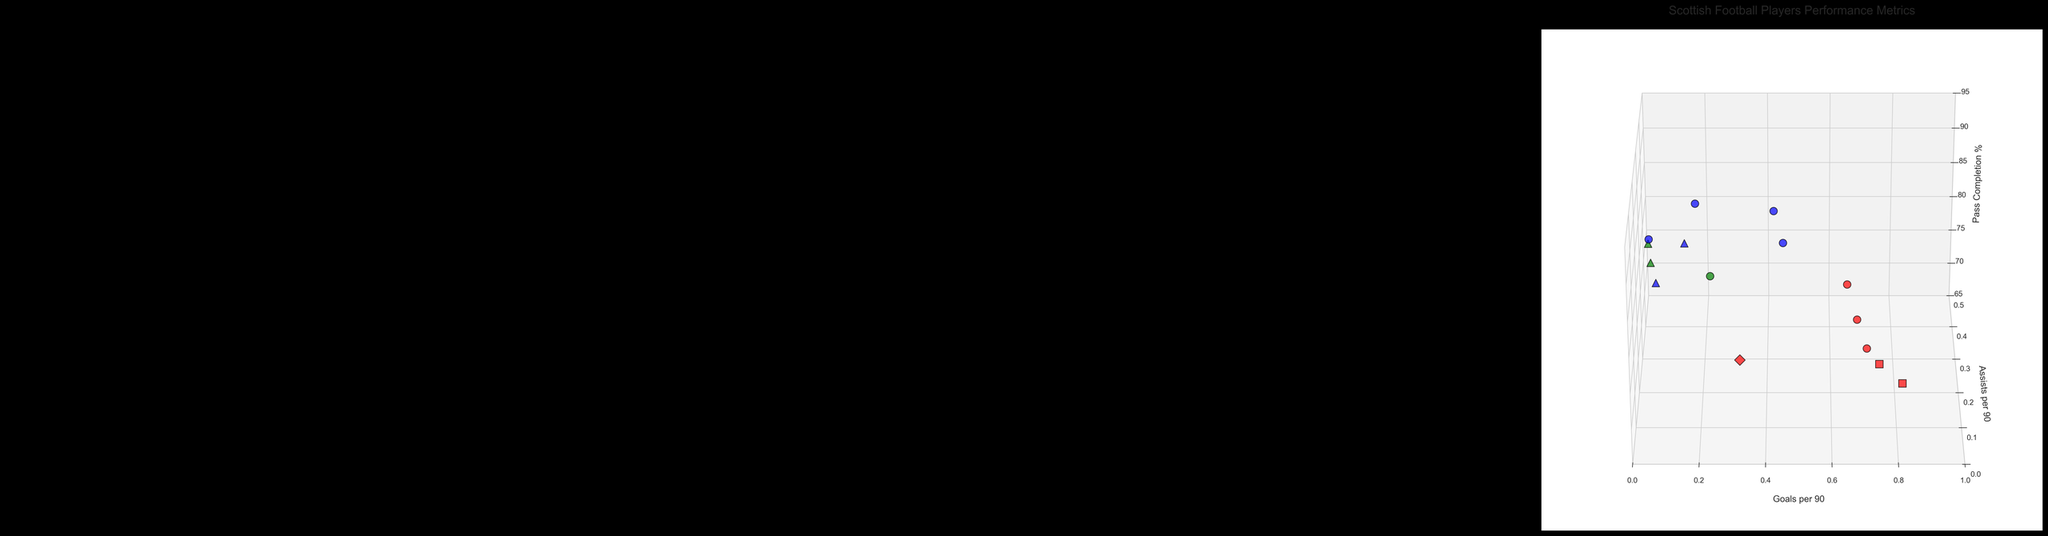What is the title of the plot? The title is generally found at the top of the figure and provides an overall description of the plot.
Answer: Scottish Football Players Performance Metrics How many legends are there in the plot? By visual inspection, one can see that there are two distinct legends typically placed on the side of the figure—one for positions and one for leagues.
Answer: Two What color represents forward players in the plot? The colors associated with each position are generally indicated in the legend. For forward players, it is red.
Answer: Red Which league uses a square marker in the plot? The type of marker associated with each league can be identified in the legend. The square marker represents the Scottish Championship.
Answer: Scottish Championship What is the range of the 'Goals per 90' axis? The axis range is usually set and labeled along the axis. In this case, the range is from 0 to 1.
Answer: 0 to 1 Which player has the highest goals per 90 minutes in the plot? To find the player with the highest value along the 'Goals per 90' axis, one needs to look at the data points positioned closest to the maximum value (1). Lawrence Shankland has the highest with 0.82.
Answer: Lawrence Shankland Which position generally has higher 'Pass Completion' percentages in the plot, midfielders or defenders? By comparing the data points for midfielders (blue) and defenders (green), one observes that midfielders generally have higher 'Pass Completion' percentages.
Answer: Midfielders Among forwards, who has the highest 'Assists per 90' in the plot? By comparing the 'Assists per 90' values specifically among forwards (red data points), Odsonne Edouard has the highest with 0.25.
Answer: Odsonne Edouard Which player from the Scottish Premiership has the best pass completion rate? Looking at the 'Pass Completion' values for players from the Scottish Premiership, Scott Brown has the highest with 89.3%.
Answer: Scott Brown How do the average 'Goals per 90' of forwards in the Scottish Premiership compare to those in the English Championship? To solve this, calculate the average 'Goals per 90' for forwards in both leagues. Scottish Premiership forwards: (0.68 + 0.71 + 0.65)/3 = 0.68. English Championship forward: Only one player with 0.32. Comparatively, forwards in the Scottish Premiership have higher average goals.
Answer: Higher in the Scottish Premiership 